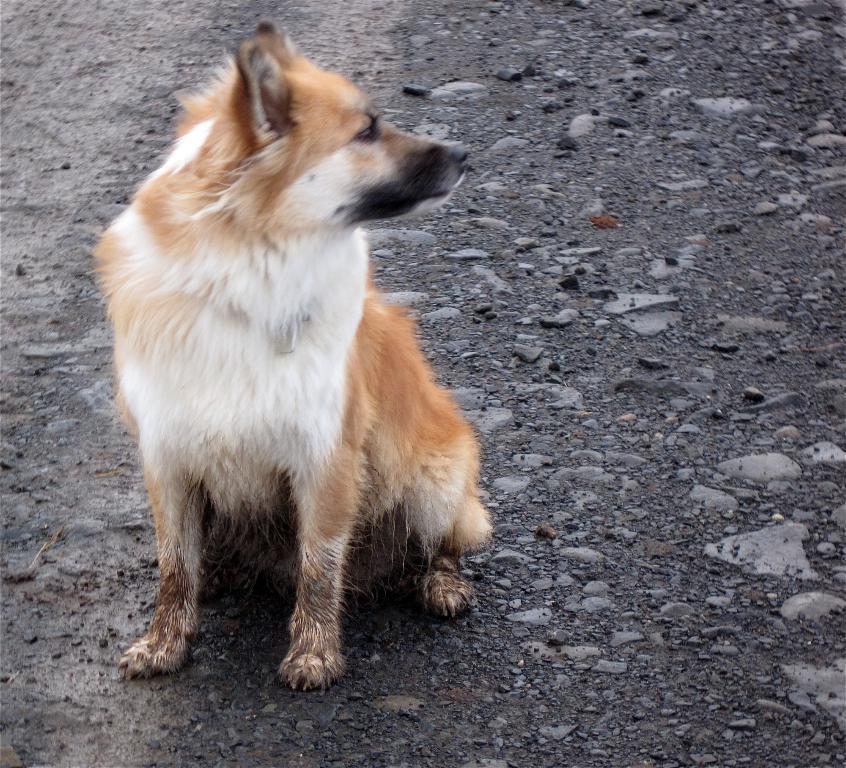Describe this image in one or two sentences. In this image, we can see a brown and white color dog on the ground. 